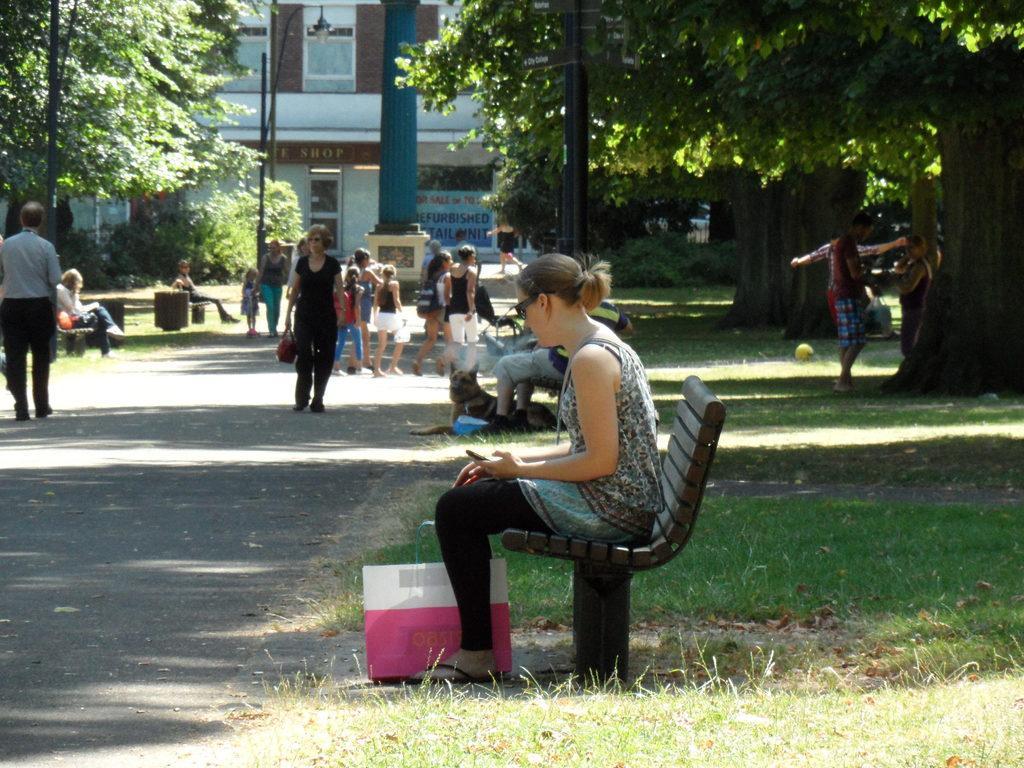Can you describe this image briefly? In this picture there is a woman sitting on the bench, behind her there are people standing. 